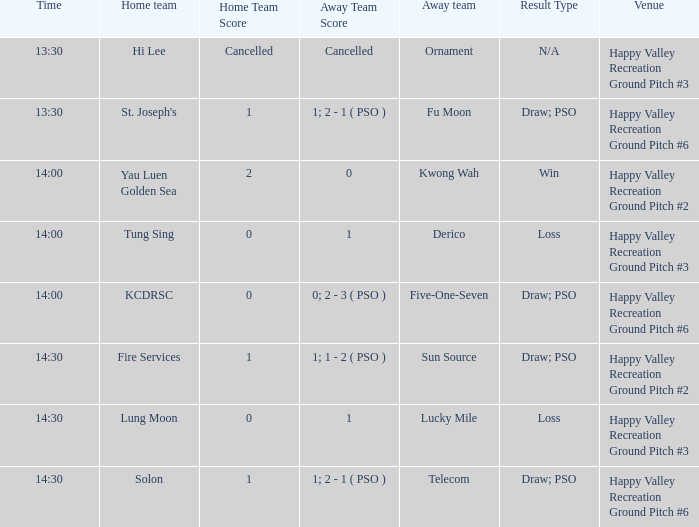What is the away team when solon was the home team? Telecom. 